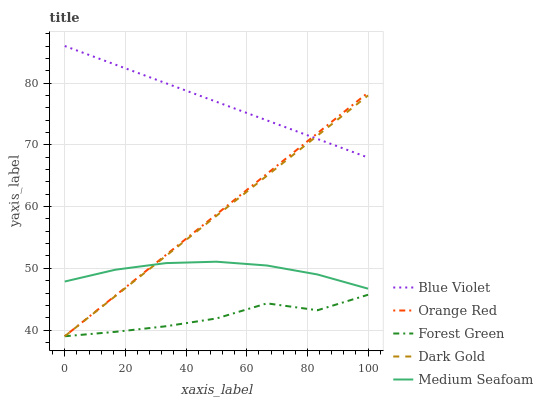Does Forest Green have the minimum area under the curve?
Answer yes or no. Yes. Does Blue Violet have the maximum area under the curve?
Answer yes or no. Yes. Does Medium Seafoam have the minimum area under the curve?
Answer yes or no. No. Does Medium Seafoam have the maximum area under the curve?
Answer yes or no. No. Is Orange Red the smoothest?
Answer yes or no. Yes. Is Forest Green the roughest?
Answer yes or no. Yes. Is Medium Seafoam the smoothest?
Answer yes or no. No. Is Medium Seafoam the roughest?
Answer yes or no. No. Does Forest Green have the lowest value?
Answer yes or no. Yes. Does Medium Seafoam have the lowest value?
Answer yes or no. No. Does Blue Violet have the highest value?
Answer yes or no. Yes. Does Medium Seafoam have the highest value?
Answer yes or no. No. Is Forest Green less than Blue Violet?
Answer yes or no. Yes. Is Medium Seafoam greater than Forest Green?
Answer yes or no. Yes. Does Orange Red intersect Blue Violet?
Answer yes or no. Yes. Is Orange Red less than Blue Violet?
Answer yes or no. No. Is Orange Red greater than Blue Violet?
Answer yes or no. No. Does Forest Green intersect Blue Violet?
Answer yes or no. No. 